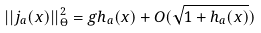Convert formula to latex. <formula><loc_0><loc_0><loc_500><loc_500>| | j _ { a } ( x ) | | _ { \Theta } ^ { 2 } = g h _ { a } ( x ) + O ( \sqrt { 1 + h _ { a } ( x ) } )</formula> 